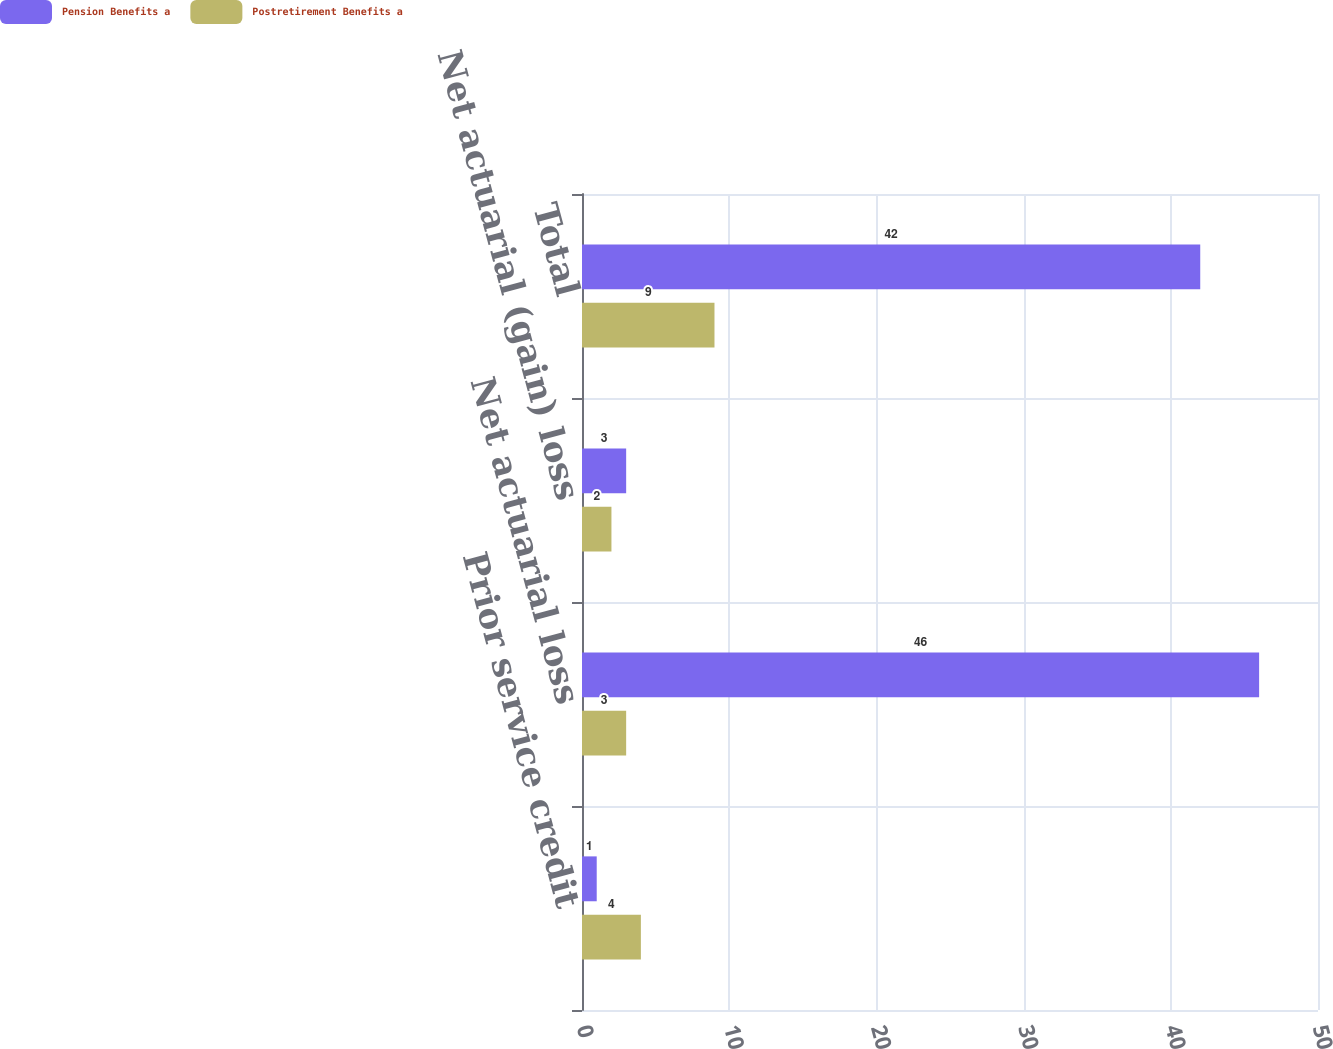Convert chart to OTSL. <chart><loc_0><loc_0><loc_500><loc_500><stacked_bar_chart><ecel><fcel>Prior service credit<fcel>Net actuarial loss<fcel>Net actuarial (gain) loss<fcel>Total<nl><fcel>Pension Benefits a<fcel>1<fcel>46<fcel>3<fcel>42<nl><fcel>Postretirement Benefits a<fcel>4<fcel>3<fcel>2<fcel>9<nl></chart> 